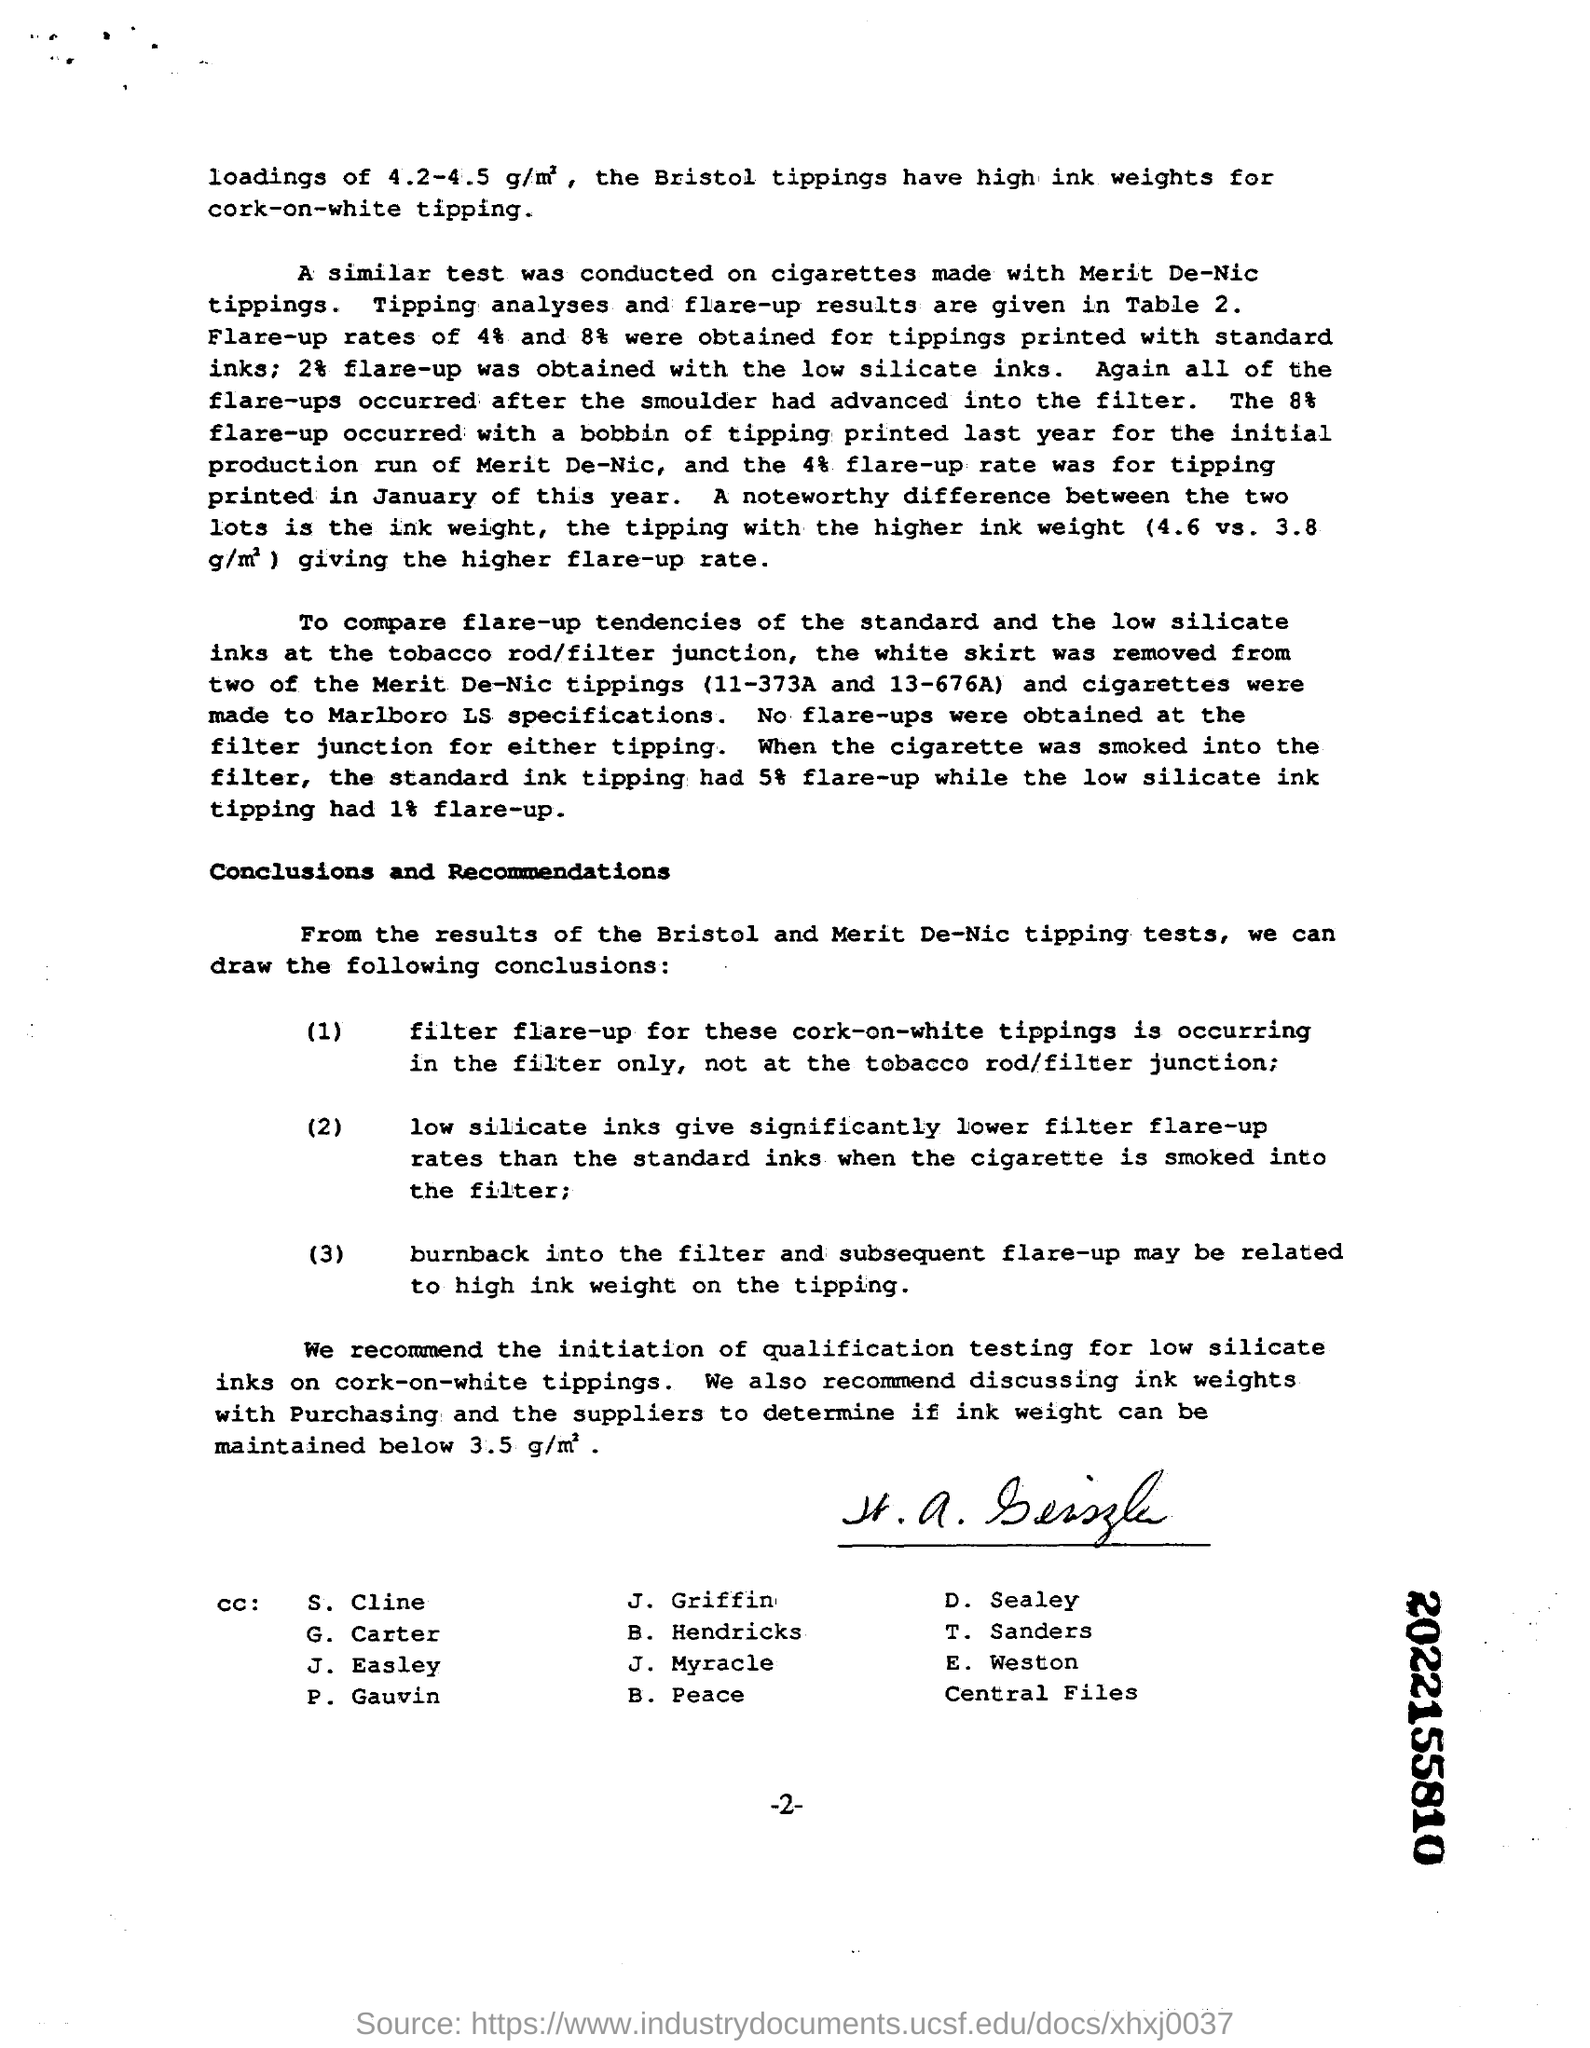For what does the Bristol tippings have high ink weights for?
Your answer should be compact. Cork-on-white tipping. When the cigarette was smoked into the filter, what had 5% flare-up while the low silicate ink tipping had 1% flare-up?
Give a very brief answer. Standard ink tipping. Which inks give significantly lower filter flare-up rates?
Keep it short and to the point. Low silicate inks. What is the 10 digits number written bold on the paper?
Your answer should be very brief. 2022155810. 